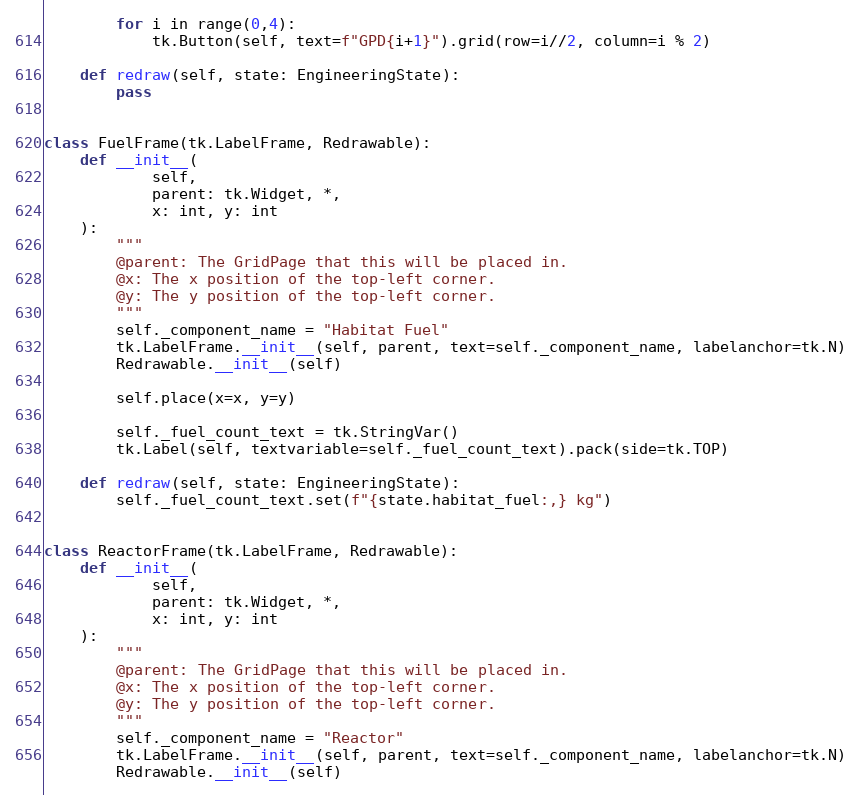Convert code to text. <code><loc_0><loc_0><loc_500><loc_500><_Python_>        for i in range(0,4):
            tk.Button(self, text=f"GPD{i+1}").grid(row=i//2, column=i % 2)

    def redraw(self, state: EngineeringState):
        pass


class FuelFrame(tk.LabelFrame, Redrawable):
    def __init__(
            self,
            parent: tk.Widget, *,
            x: int, y: int
    ):
        """
        @parent: The GridPage that this will be placed in.
        @x: The x position of the top-left corner.
        @y: The y position of the top-left corner.
        """
        self._component_name = "Habitat Fuel"
        tk.LabelFrame.__init__(self, parent, text=self._component_name, labelanchor=tk.N)
        Redrawable.__init__(self)

        self.place(x=x, y=y)

        self._fuel_count_text = tk.StringVar()
        tk.Label(self, textvariable=self._fuel_count_text).pack(side=tk.TOP)

    def redraw(self, state: EngineeringState):
        self._fuel_count_text.set(f"{state.habitat_fuel:,} kg")


class ReactorFrame(tk.LabelFrame, Redrawable):
    def __init__(
            self,
            parent: tk.Widget, *,
            x: int, y: int
    ):
        """
        @parent: The GridPage that this will be placed in.
        @x: The x position of the top-left corner.
        @y: The y position of the top-left corner.
        """
        self._component_name = "Reactor"
        tk.LabelFrame.__init__(self, parent, text=self._component_name, labelanchor=tk.N)
        Redrawable.__init__(self)
</code> 